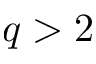<formula> <loc_0><loc_0><loc_500><loc_500>q > 2</formula> 